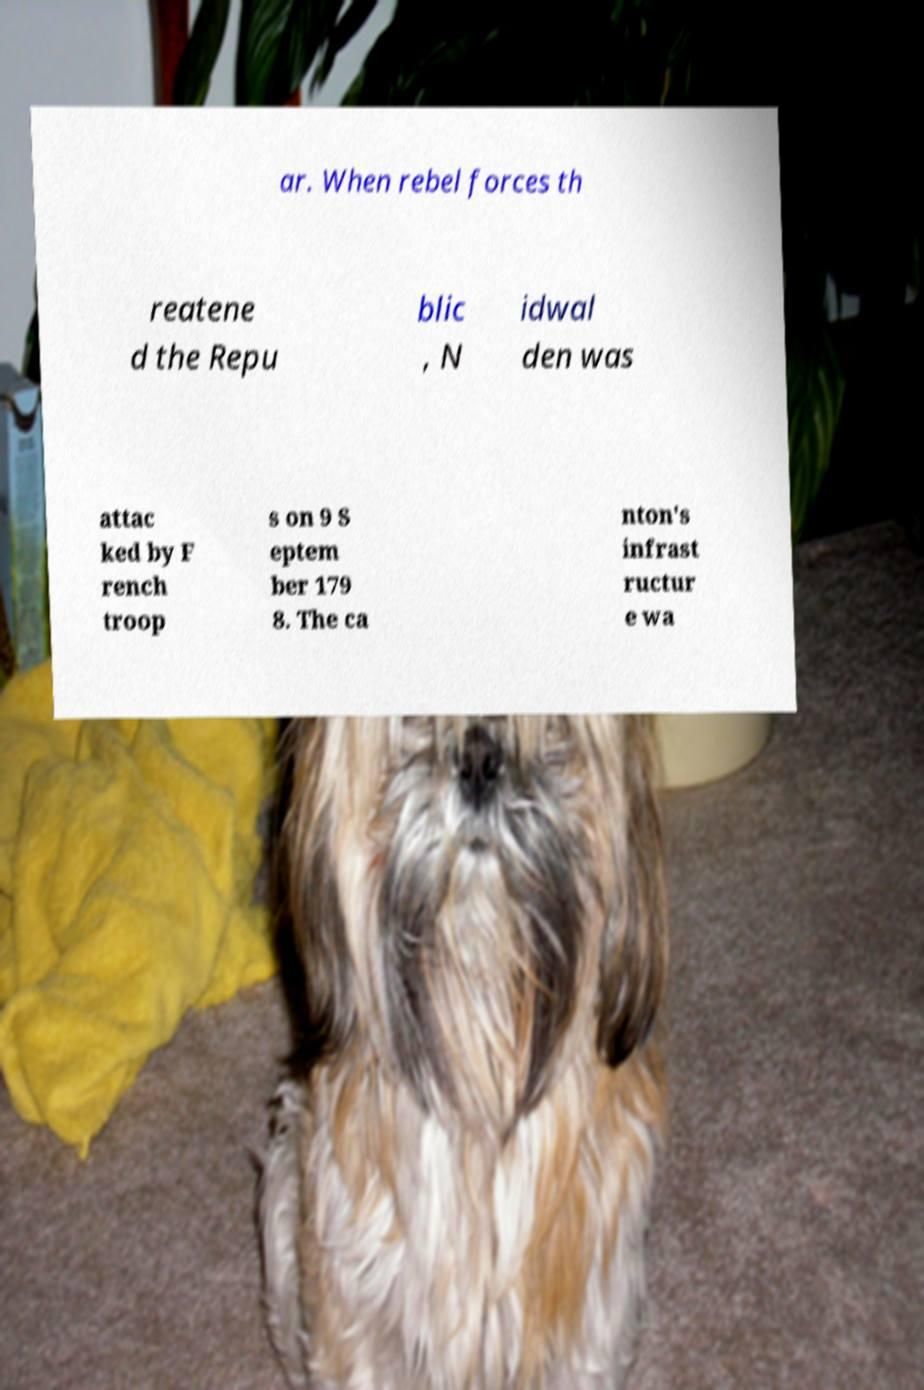There's text embedded in this image that I need extracted. Can you transcribe it verbatim? ar. When rebel forces th reatene d the Repu blic , N idwal den was attac ked by F rench troop s on 9 S eptem ber 179 8. The ca nton's infrast ructur e wa 